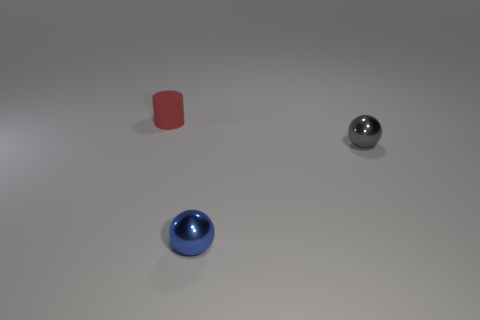How many other objects have the same material as the small gray thing?
Your response must be concise. 1. What number of small things are either brown metal objects or gray metallic objects?
Offer a very short reply. 1. There is a object that is left of the gray object and behind the blue object; what shape is it?
Your answer should be very brief. Cylinder. Does the blue sphere have the same material as the gray object?
Keep it short and to the point. Yes. There is a rubber cylinder that is the same size as the gray metallic ball; what color is it?
Keep it short and to the point. Red. There is a small thing that is both to the left of the gray object and to the right of the small red thing; what color is it?
Your answer should be very brief. Blue. What is the size of the metal object that is left of the small metal sphere right of the shiny object in front of the gray sphere?
Offer a very short reply. Small. What material is the blue sphere?
Give a very brief answer. Metal. Is the tiny red object made of the same material as the ball behind the small blue metal thing?
Offer a terse response. No. Is there any other thing that has the same color as the tiny rubber cylinder?
Provide a succinct answer. No. 